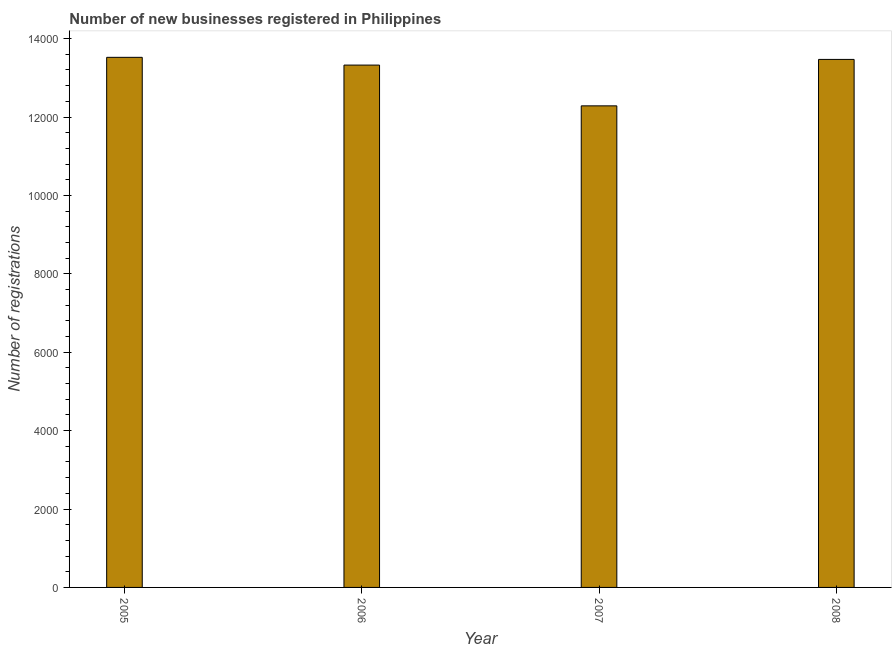Does the graph contain grids?
Your answer should be very brief. No. What is the title of the graph?
Offer a very short reply. Number of new businesses registered in Philippines. What is the label or title of the Y-axis?
Keep it short and to the point. Number of registrations. What is the number of new business registrations in 2005?
Provide a short and direct response. 1.35e+04. Across all years, what is the maximum number of new business registrations?
Your answer should be very brief. 1.35e+04. Across all years, what is the minimum number of new business registrations?
Offer a terse response. 1.23e+04. What is the sum of the number of new business registrations?
Give a very brief answer. 5.26e+04. What is the difference between the number of new business registrations in 2005 and 2008?
Provide a short and direct response. 53. What is the average number of new business registrations per year?
Provide a succinct answer. 1.32e+04. What is the median number of new business registrations?
Your answer should be compact. 1.34e+04. What is the ratio of the number of new business registrations in 2005 to that in 2006?
Your answer should be very brief. 1.01. Is the sum of the number of new business registrations in 2007 and 2008 greater than the maximum number of new business registrations across all years?
Your answer should be compact. Yes. What is the difference between the highest and the lowest number of new business registrations?
Make the answer very short. 1238. In how many years, is the number of new business registrations greater than the average number of new business registrations taken over all years?
Offer a terse response. 3. How many bars are there?
Your answer should be compact. 4. Are all the bars in the graph horizontal?
Make the answer very short. No. How many years are there in the graph?
Ensure brevity in your answer.  4. What is the difference between two consecutive major ticks on the Y-axis?
Keep it short and to the point. 2000. Are the values on the major ticks of Y-axis written in scientific E-notation?
Ensure brevity in your answer.  No. What is the Number of registrations in 2005?
Your answer should be very brief. 1.35e+04. What is the Number of registrations of 2006?
Your answer should be very brief. 1.33e+04. What is the Number of registrations in 2007?
Offer a very short reply. 1.23e+04. What is the Number of registrations in 2008?
Offer a very short reply. 1.35e+04. What is the difference between the Number of registrations in 2005 and 2006?
Provide a short and direct response. 198. What is the difference between the Number of registrations in 2005 and 2007?
Make the answer very short. 1238. What is the difference between the Number of registrations in 2005 and 2008?
Your response must be concise. 53. What is the difference between the Number of registrations in 2006 and 2007?
Give a very brief answer. 1040. What is the difference between the Number of registrations in 2006 and 2008?
Your answer should be compact. -145. What is the difference between the Number of registrations in 2007 and 2008?
Your answer should be very brief. -1185. What is the ratio of the Number of registrations in 2005 to that in 2007?
Provide a succinct answer. 1.1. What is the ratio of the Number of registrations in 2006 to that in 2007?
Your answer should be compact. 1.08. What is the ratio of the Number of registrations in 2007 to that in 2008?
Provide a succinct answer. 0.91. 